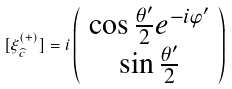Convert formula to latex. <formula><loc_0><loc_0><loc_500><loc_500>[ \xi _ { \widehat { c } } ^ { ( + ) } ] = i \left ( \begin{array} { c } \cos \frac { \theta ^ { \prime } } 2 e ^ { - i \varphi ^ { \prime } } \\ \sin \frac { \theta ^ { \prime } } 2 \end{array} \right )</formula> 